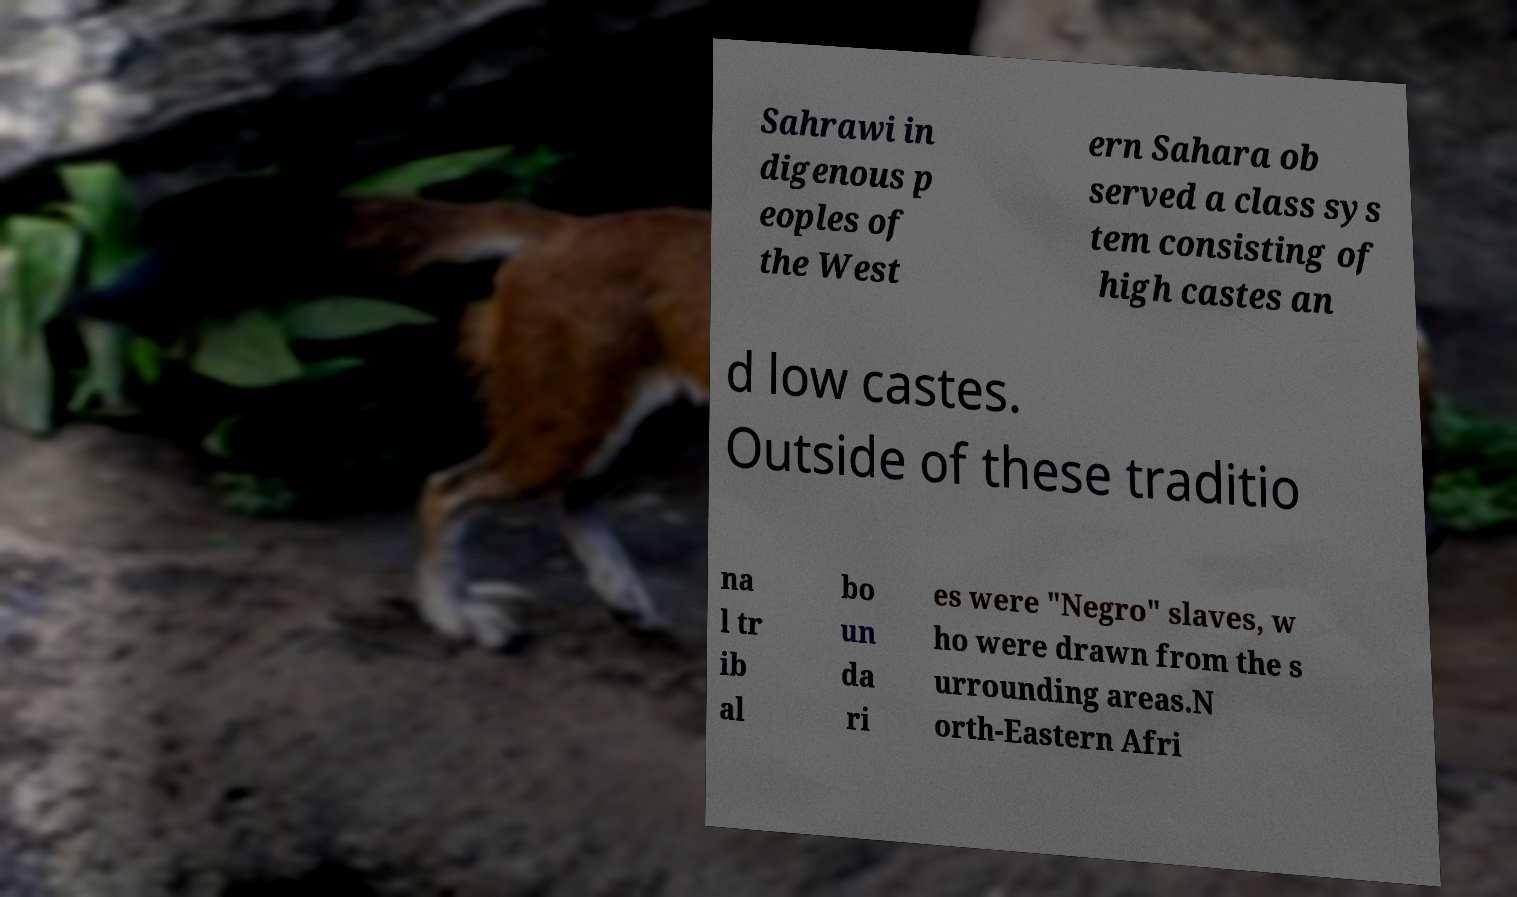Could you extract and type out the text from this image? Sahrawi in digenous p eoples of the West ern Sahara ob served a class sys tem consisting of high castes an d low castes. Outside of these traditio na l tr ib al bo un da ri es were "Negro" slaves, w ho were drawn from the s urrounding areas.N orth-Eastern Afri 